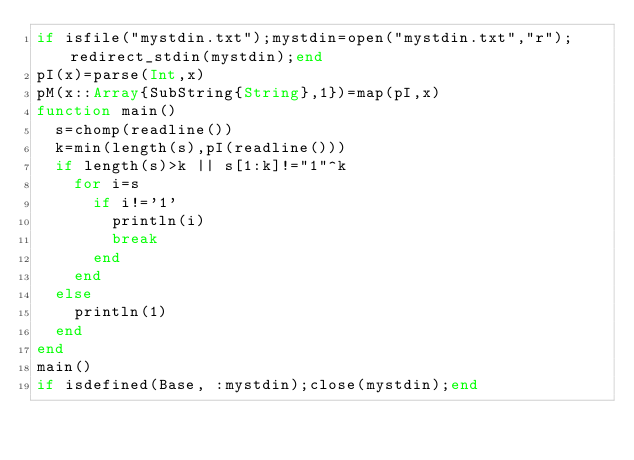Convert code to text. <code><loc_0><loc_0><loc_500><loc_500><_Julia_>if isfile("mystdin.txt");mystdin=open("mystdin.txt","r");redirect_stdin(mystdin);end
pI(x)=parse(Int,x)
pM(x::Array{SubString{String},1})=map(pI,x)
function main()
  s=chomp(readline())
  k=min(length(s),pI(readline()))
  if length(s)>k || s[1:k]!="1"^k
    for i=s
      if i!='1'
        println(i)
        break
      end
    end
  else
    println(1)
  end
end
main()
if isdefined(Base, :mystdin);close(mystdin);end</code> 